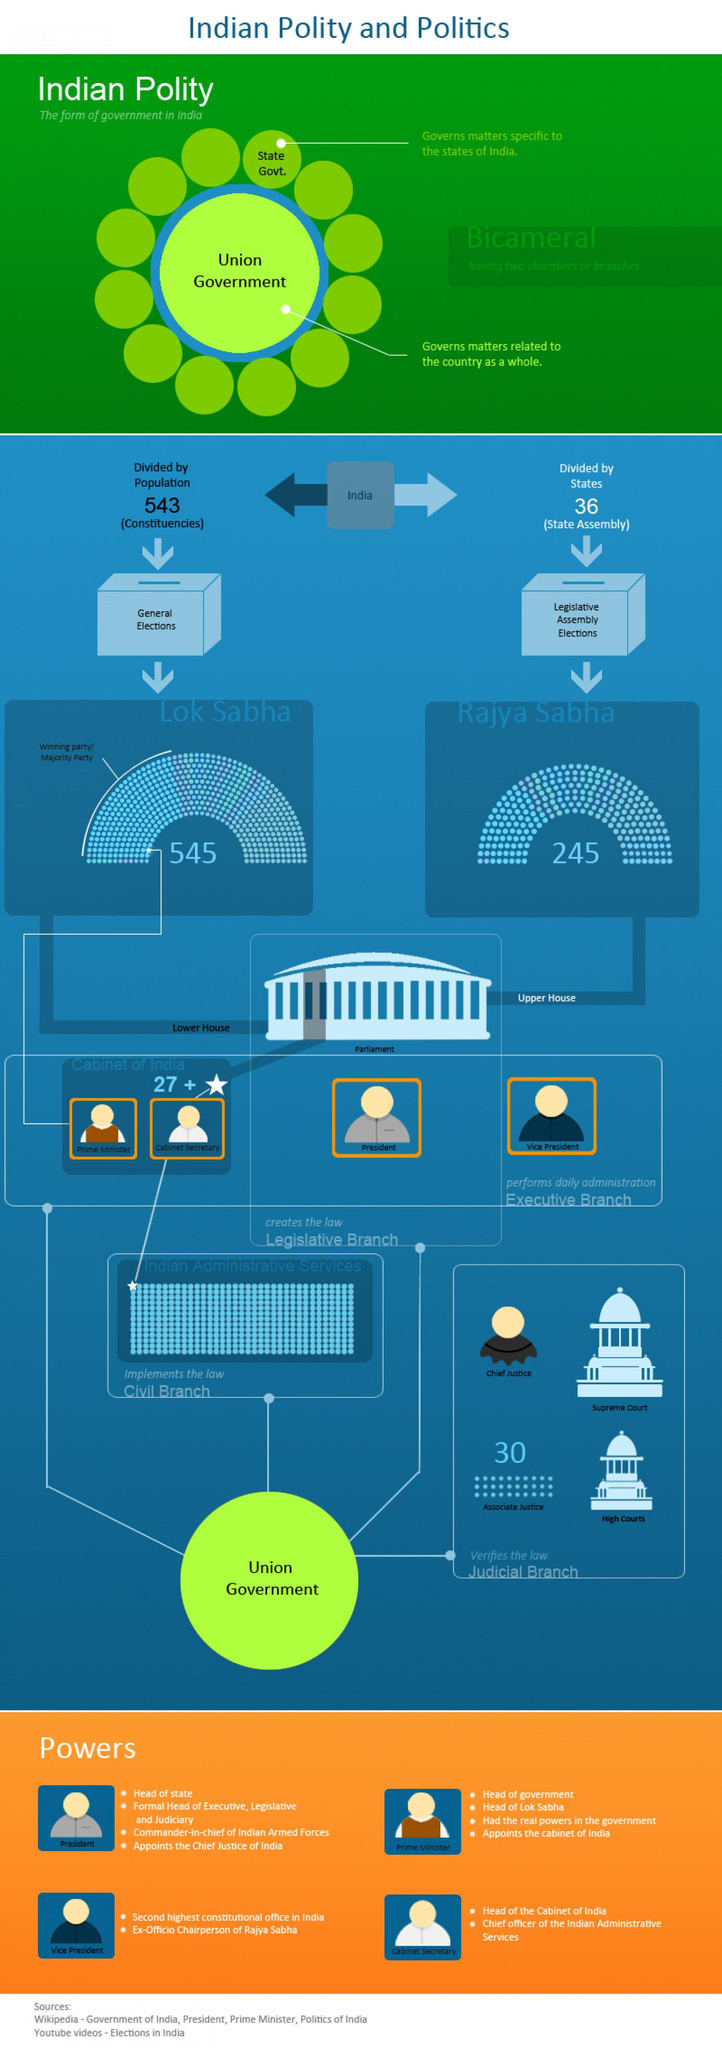Outline some significant characteristics in this image. The Rajya Sabha members are elected through Legislative Assembly Elections. The Lok Sabha is the lower house of India's bicameral Parliament. The Union Government governs the matters related to the entire country. The number of members in the Lok Sabha in India is 545. There are 543 Parliamentary constituencies in India. 